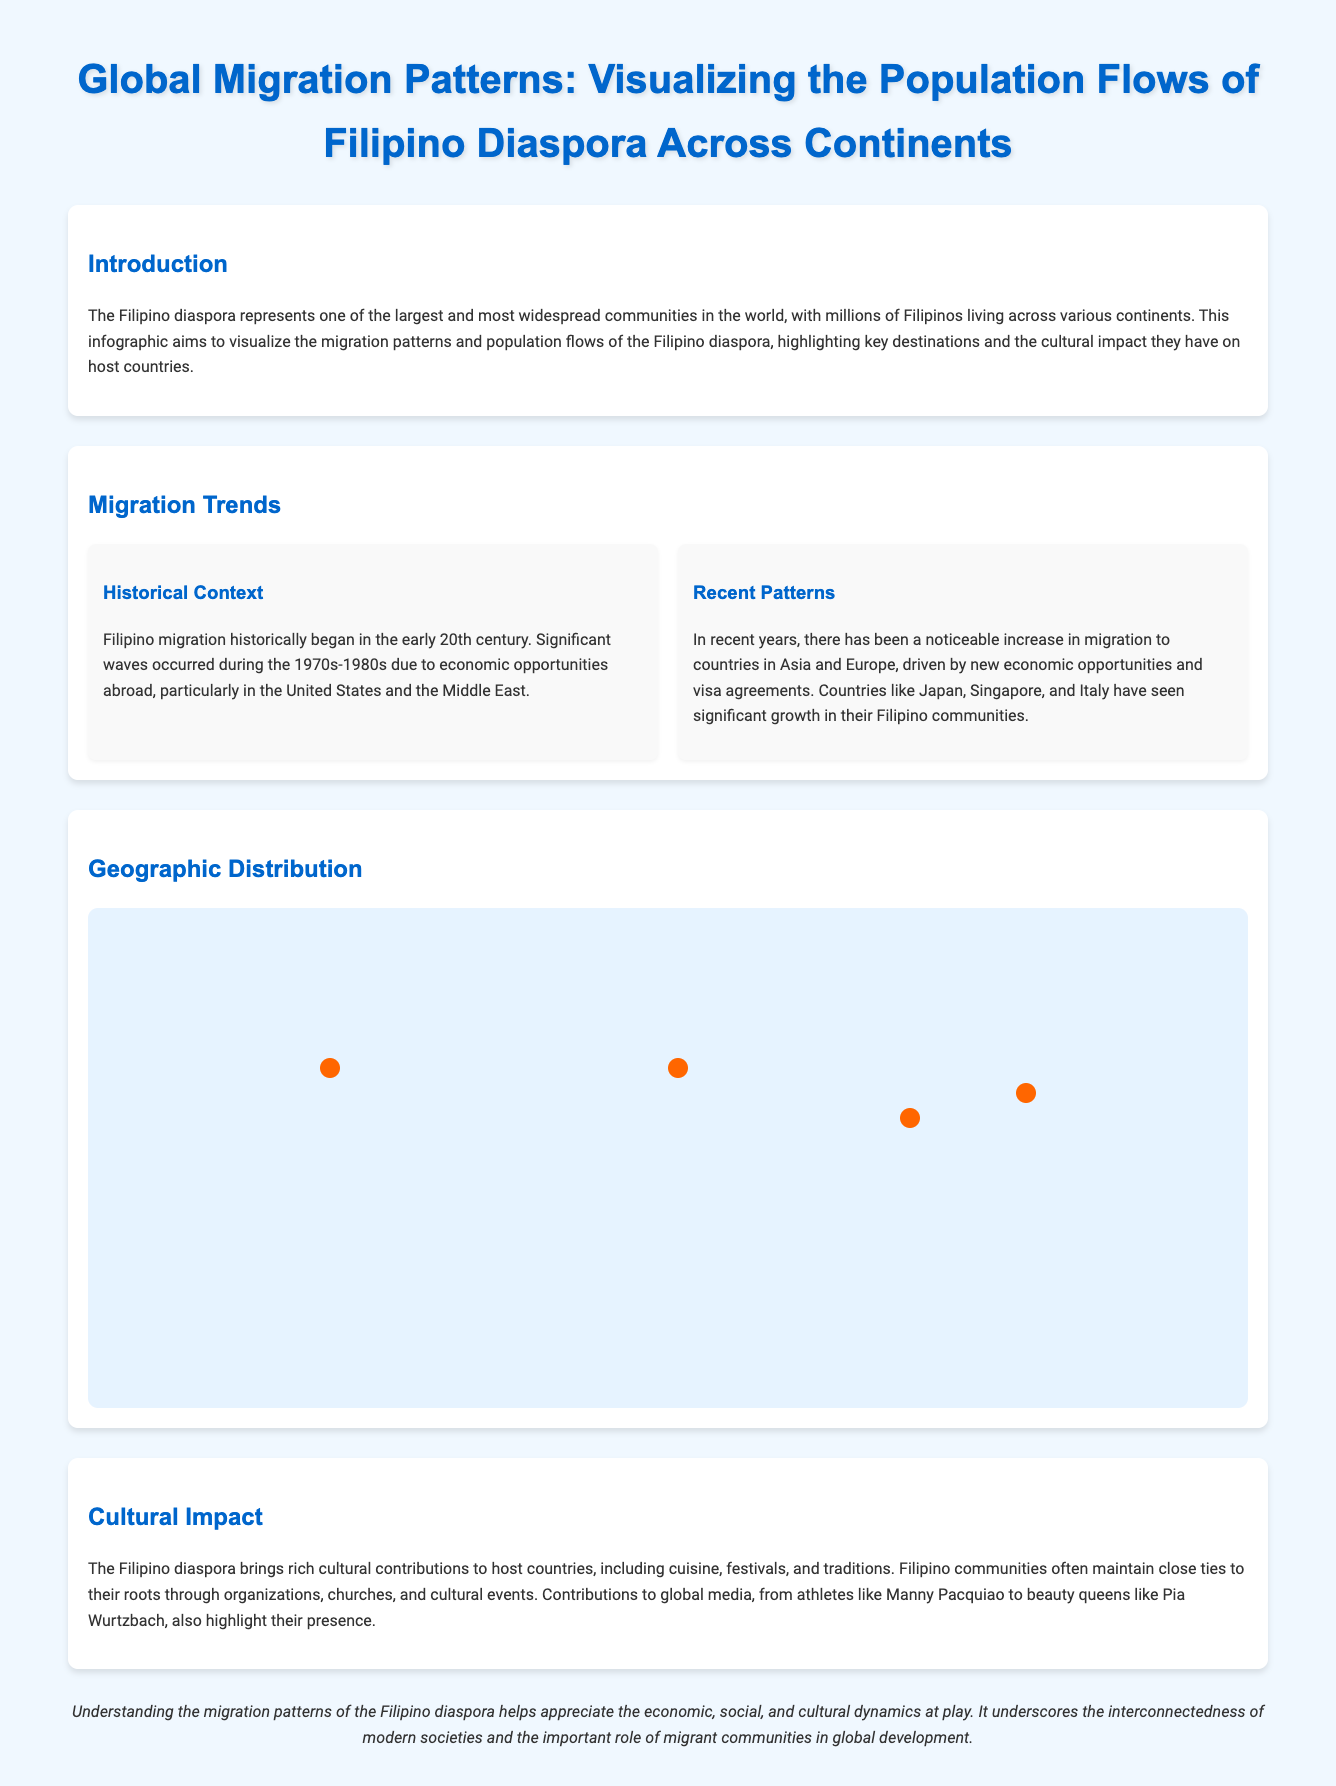What is the title of the infographic? The title provides an overview of the content being presented in the document.
Answer: Global Migration Patterns: Visualizing the Population Flows of Filipino Diaspora Across Continents How many Filipinos are in the USA? This information is found in the geographic distribution section, naming a specific country and its Filipino population.
Answer: 4 million Filipinos Which country has a large Filipino workforce? This refers to one of the points highlighted in the geographic distribution section of the infographic.
Answer: Saudi Arabia What decade saw significant Filipino migration due to economic opportunities? The historical context discusses critical periods that impacted migration trends.
Answer: 1970s-1980s Which countries have seen significant growth in their Filipino communities recently? This question connects recent migration trends with specific countries mentioned in the document.
Answer: Japan, Singapore, and Italy What cultural contributions do Filipinos bring to host countries? The cultural impact section covers the themes of what the diaspora contributes culturally to other nations.
Answer: Cuisine, festivals, and traditions What role do Filipino communities play in maintaining their cultural identity? The cultural impact section addresses the methods used by the diaspora to preserve their heritage.
Answer: Organizations, churches, and cultural events What does understanding migration patterns help appreciate? This conclusion summarizes the significance of recognizing migration trends in context.
Answer: Economic, social, and cultural dynamics How is the geographical distribution presented visually? The format of the infographic allows for visual representation of population flows using points on a map.
Answer: Map with points 